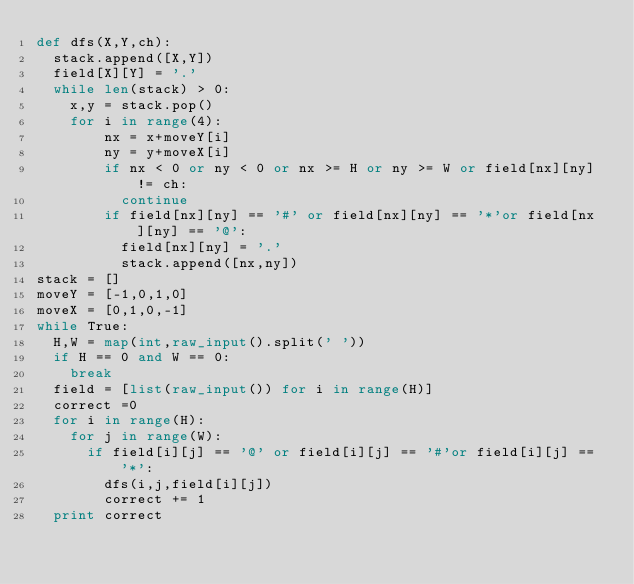Convert code to text. <code><loc_0><loc_0><loc_500><loc_500><_Python_>def dfs(X,Y,ch):
	stack.append([X,Y])
	field[X][Y] = '.'
	while len(stack) > 0:
		x,y = stack.pop()
		for i in range(4):
				nx = x+moveY[i]
				ny = y+moveX[i]
				if nx < 0 or ny < 0 or nx >= H or ny >= W or field[nx][ny] != ch:
					continue
				if field[nx][ny] == '#' or field[nx][ny] == '*'or field[nx][ny] == '@':
					field[nx][ny] = '.'
					stack.append([nx,ny])
stack = []
moveY = [-1,0,1,0]
moveX = [0,1,0,-1]
while True:
	H,W = map(int,raw_input().split(' '))
	if H == 0 and W == 0:
		break
	field = [list(raw_input()) for i in range(H)]
	correct =0
	for i in range(H):
		for j in range(W):
			if field[i][j] == '@' or field[i][j] == '#'or field[i][j] == '*':
				dfs(i,j,field[i][j])
				correct += 1
	print correct</code> 